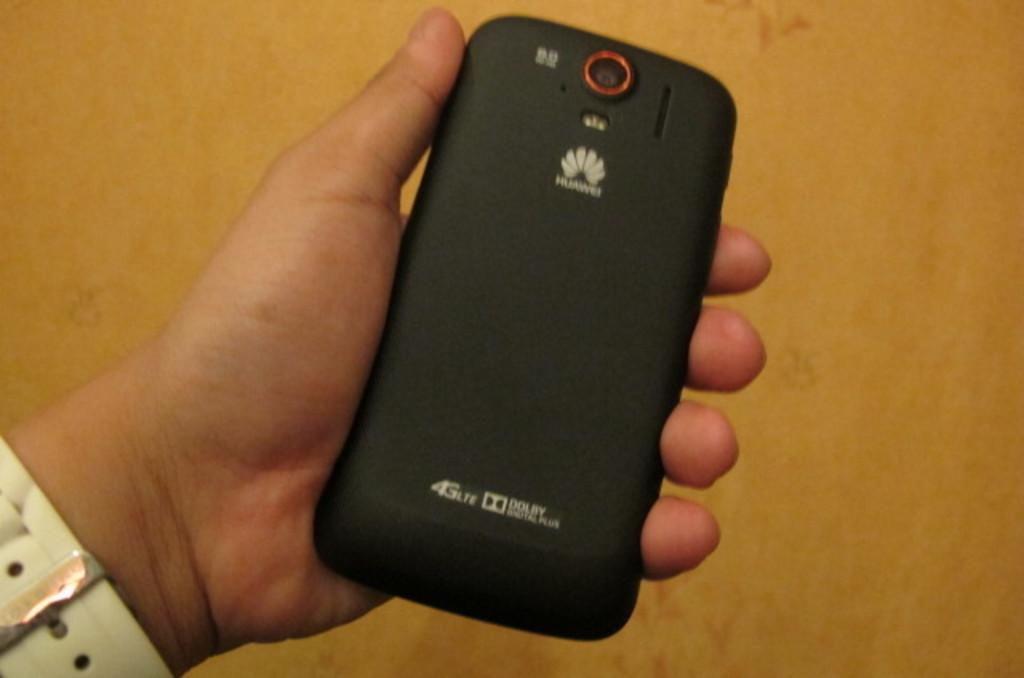<image>
Provide a brief description of the given image. The back of a phone case that supports Dolby sound 